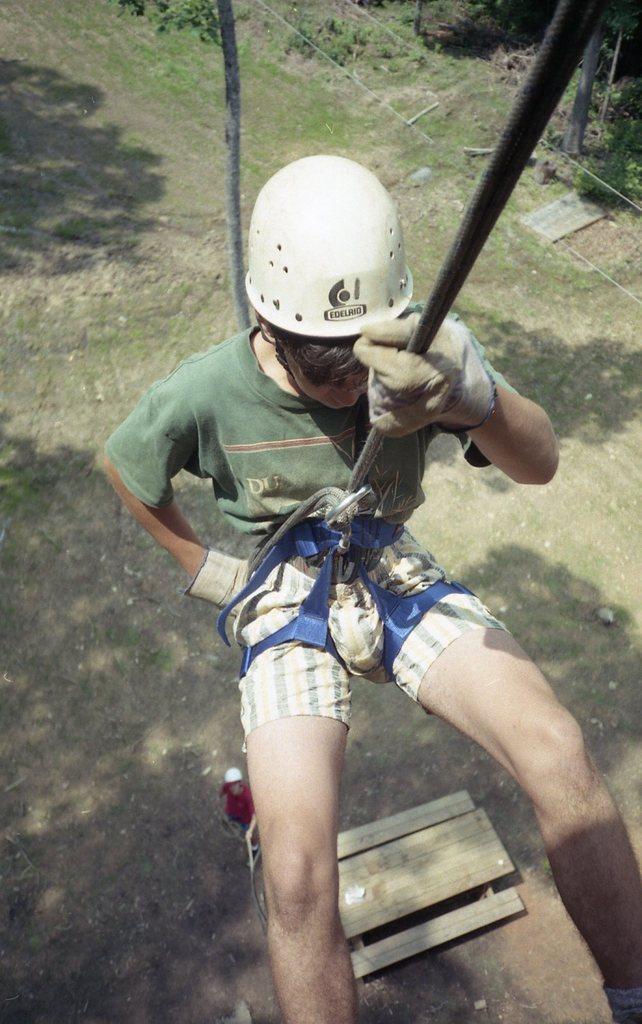Can you describe this image briefly? In this image we can see a person abseiling, there are some trees, plants and other objects on the ground. 